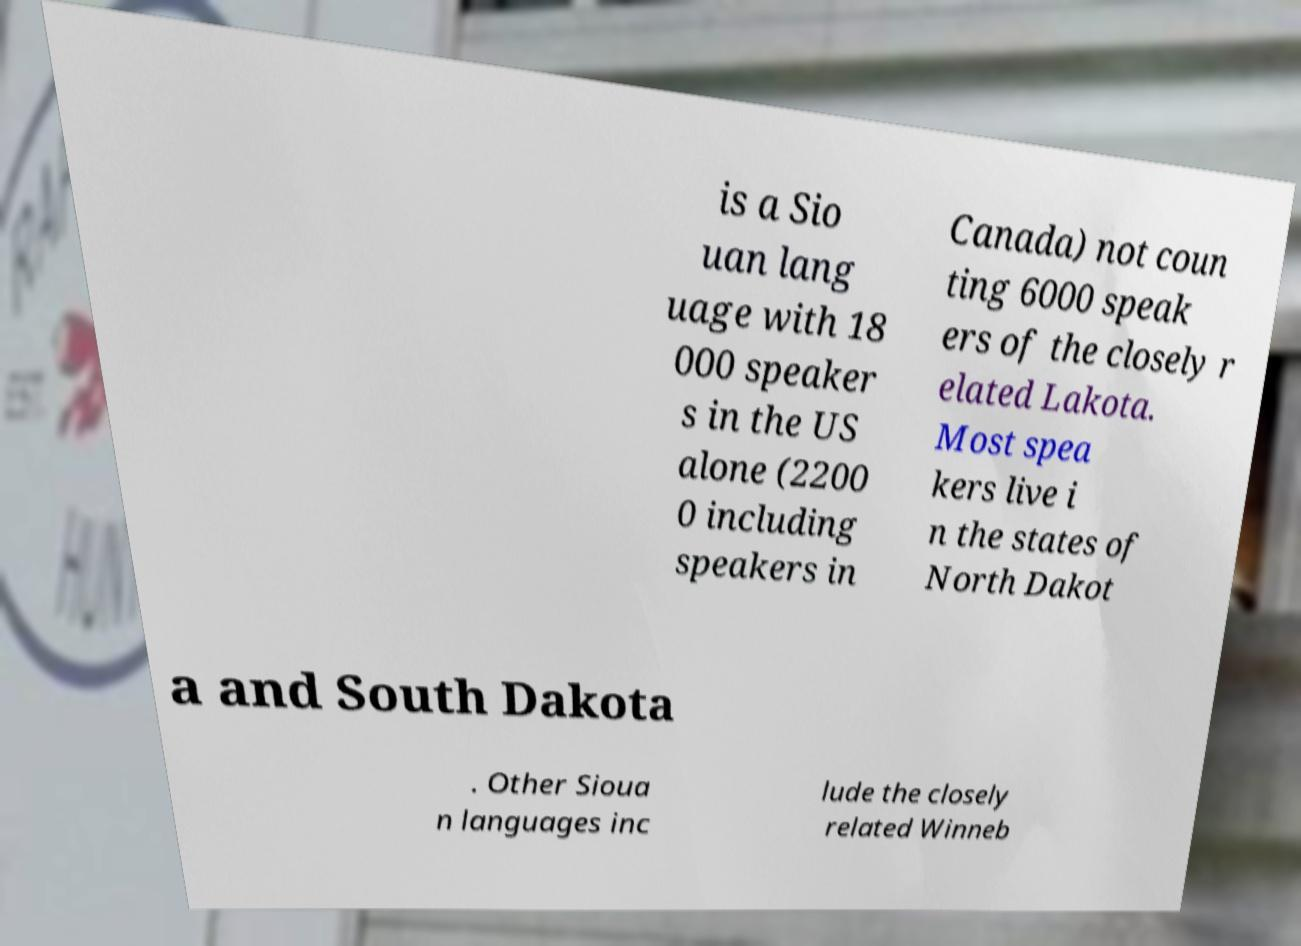For documentation purposes, I need the text within this image transcribed. Could you provide that? is a Sio uan lang uage with 18 000 speaker s in the US alone (2200 0 including speakers in Canada) not coun ting 6000 speak ers of the closely r elated Lakota. Most spea kers live i n the states of North Dakot a and South Dakota . Other Sioua n languages inc lude the closely related Winneb 